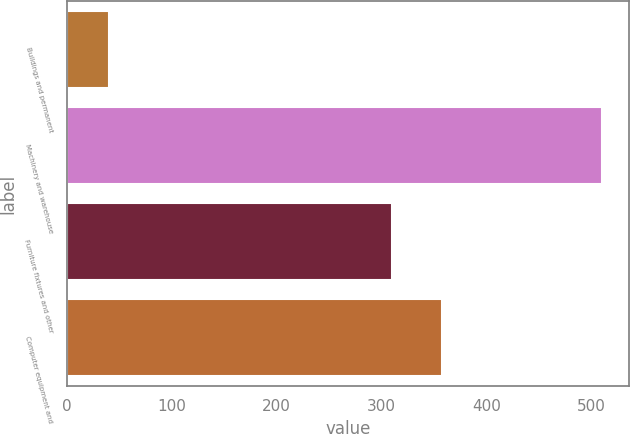Convert chart to OTSL. <chart><loc_0><loc_0><loc_500><loc_500><bar_chart><fcel>Buildings and permanent<fcel>Machinery and warehouse<fcel>Furniture fixtures and other<fcel>Computer equipment and<nl><fcel>40<fcel>510<fcel>310<fcel>357<nl></chart> 